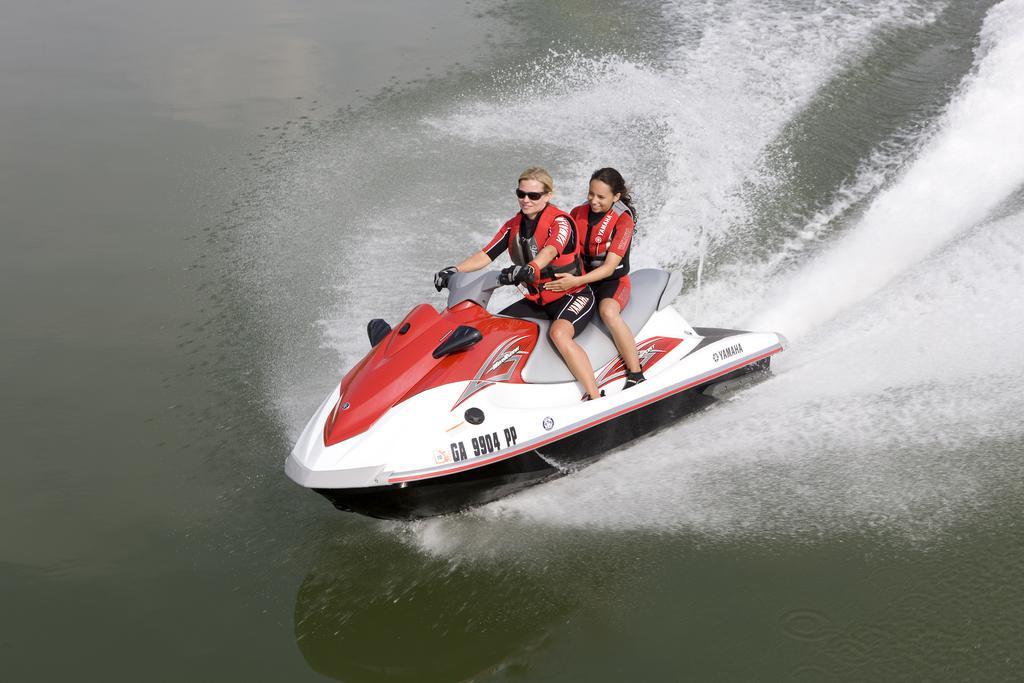Please provide a concise description of this image. In this image I can see a Jet Ski on the water. On this two people are wearing red color jackets, sitting and smiling. 